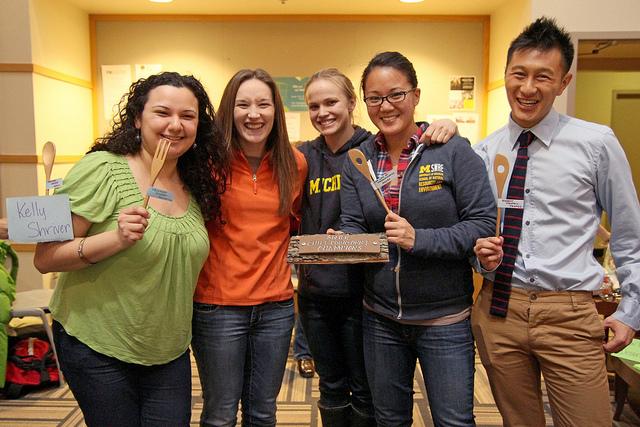How many people are smiling?
Quick response, please. 5. Are these people coworkers?
Quick response, please. Yes. How many men are in the picture?
Quick response, please. 1. How many people are standing?
Concise answer only. 5. How many men are in the photo?
Answer briefly. 1. What are the kids holding in their hands?
Keep it brief. Wooden utensils. Can these pointers control a device?
Give a very brief answer. No. Are these people part of cooking experience?
Keep it brief. Yes. How many girls are present?
Quick response, please. 4. What are the people doing?
Be succinct. Posing. 